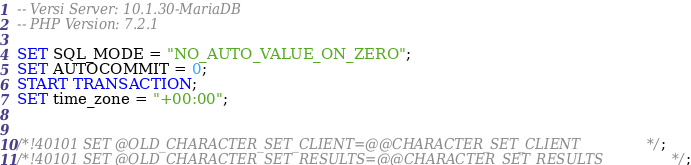Convert code to text. <code><loc_0><loc_0><loc_500><loc_500><_SQL_>-- Versi Server: 10.1.30-MariaDB
-- PHP Version: 7.2.1

SET SQL_MODE = "NO_AUTO_VALUE_ON_ZERO";
SET AUTOCOMMIT = 0;
START TRANSACTION;
SET time_zone = "+00:00";


/*!40101 SET @OLD_CHARACTER_SET_CLIENT=@@CHARACTER_SET_CLIENT */;
/*!40101 SET @OLD_CHARACTER_SET_RESULTS=@@CHARACTER_SET_RESULTS */;</code> 